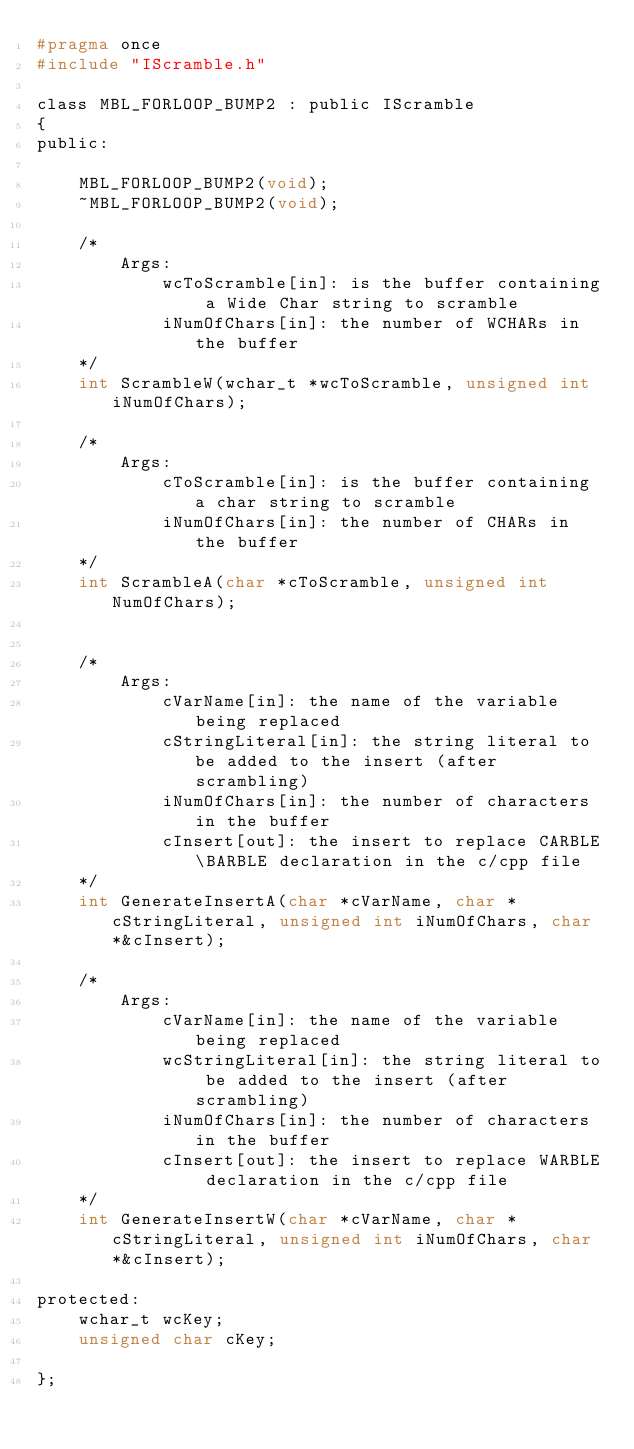<code> <loc_0><loc_0><loc_500><loc_500><_C_>#pragma once
#include "IScramble.h"

class MBL_FORLOOP_BUMP2 : public IScramble
{
public:

	MBL_FORLOOP_BUMP2(void);
	~MBL_FORLOOP_BUMP2(void);

	/*
		Args:
			wcToScramble[in]: is the buffer containing a Wide Char string to scramble
			iNumOfChars[in]: the number of WCHARs in the buffer
	*/
	int ScrambleW(wchar_t *wcToScramble, unsigned int iNumOfChars);

	/*
		Args:
			cToScramble[in]: is the buffer containing a char string to scramble
			iNumOfChars[in]: the number of CHARs in the buffer
	*/
	int ScrambleA(char *cToScramble, unsigned int NumOfChars);


	/*
		Args:
			cVarName[in]: the name of the variable being replaced
			cStringLiteral[in]: the string literal to be added to the insert (after scrambling)
			iNumOfChars[in]: the number of characters in the buffer
			cInsert[out]: the insert to replace CARBLE\BARBLE declaration in the c/cpp file
	*/
	int GenerateInsertA(char *cVarName, char *cStringLiteral, unsigned int iNumOfChars, char *&cInsert);

	/*
		Args:
			cVarName[in]: the name of the variable being replaced
			wcStringLiteral[in]: the string literal to be added to the insert (after scrambling)
			iNumOfChars[in]: the number of characters in the buffer
			cInsert[out]: the insert to replace WARBLE declaration in the c/cpp file
	*/
	int GenerateInsertW(char *cVarName, char *cStringLiteral, unsigned int iNumOfChars, char *&cInsert);

protected:
	wchar_t wcKey;
	unsigned char cKey;

};
</code> 